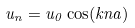Convert formula to latex. <formula><loc_0><loc_0><loc_500><loc_500>u _ { n } = u _ { 0 } \cos ( k n a )</formula> 